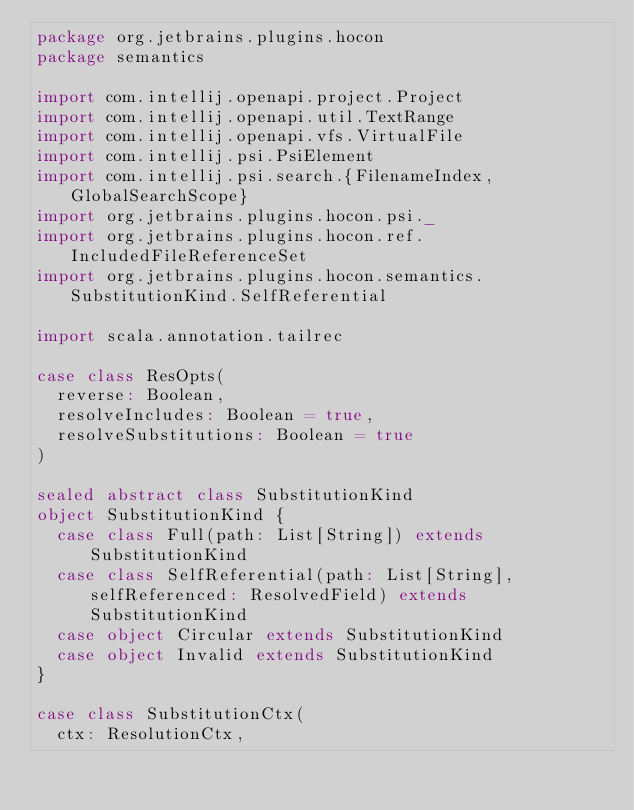<code> <loc_0><loc_0><loc_500><loc_500><_Scala_>package org.jetbrains.plugins.hocon
package semantics

import com.intellij.openapi.project.Project
import com.intellij.openapi.util.TextRange
import com.intellij.openapi.vfs.VirtualFile
import com.intellij.psi.PsiElement
import com.intellij.psi.search.{FilenameIndex, GlobalSearchScope}
import org.jetbrains.plugins.hocon.psi._
import org.jetbrains.plugins.hocon.ref.IncludedFileReferenceSet
import org.jetbrains.plugins.hocon.semantics.SubstitutionKind.SelfReferential

import scala.annotation.tailrec

case class ResOpts(
  reverse: Boolean,
  resolveIncludes: Boolean = true,
  resolveSubstitutions: Boolean = true
)

sealed abstract class SubstitutionKind
object SubstitutionKind {
  case class Full(path: List[String]) extends SubstitutionKind
  case class SelfReferential(path: List[String], selfReferenced: ResolvedField) extends SubstitutionKind
  case object Circular extends SubstitutionKind
  case object Invalid extends SubstitutionKind
}

case class SubstitutionCtx(
  ctx: ResolutionCtx,</code> 